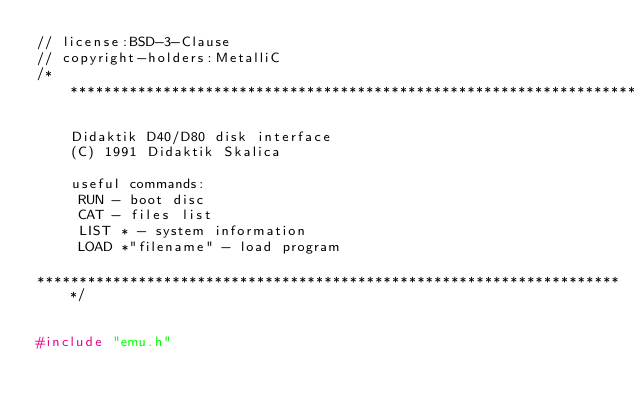<code> <loc_0><loc_0><loc_500><loc_500><_C++_>// license:BSD-3-Clause
// copyright-holders:MetalliC
/**********************************************************************

    Didaktik D40/D80 disk interface
    (C) 1991 Didaktik Skalica

    useful commands:
     RUN - boot disc
     CAT - files list
     LIST * - system information
     LOAD *"filename" - load program

**********************************************************************/


#include "emu.h"</code> 